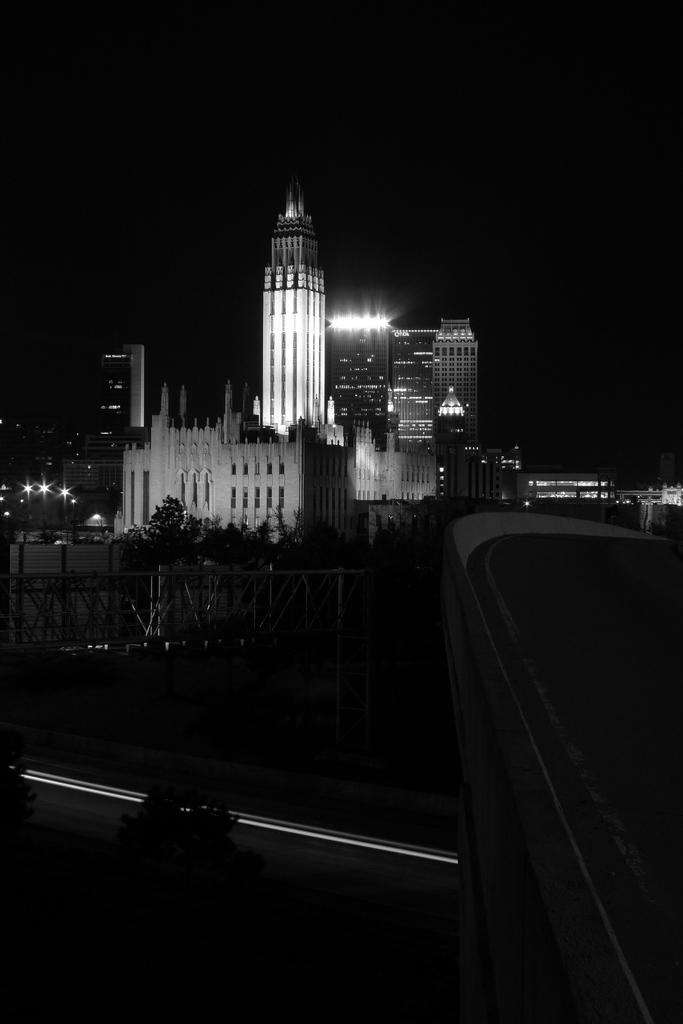What type of natural elements can be seen in the image? There are trees in the image. What type of man-made structures can be seen in the image? There are buildings and towers in the image. What type of barrier is present in the image? There is a fence in the image. What type of illumination is present in the image? There are lights in the image. What part of the natural environment is visible in the image? The sky is visible at the top of the image. What time of day was the image taken? The image was taken during nighttime. What word is being advertised on the buildings in the image? There is no advertisement present in the image, so it is not possible to determine what word might be advertised. 